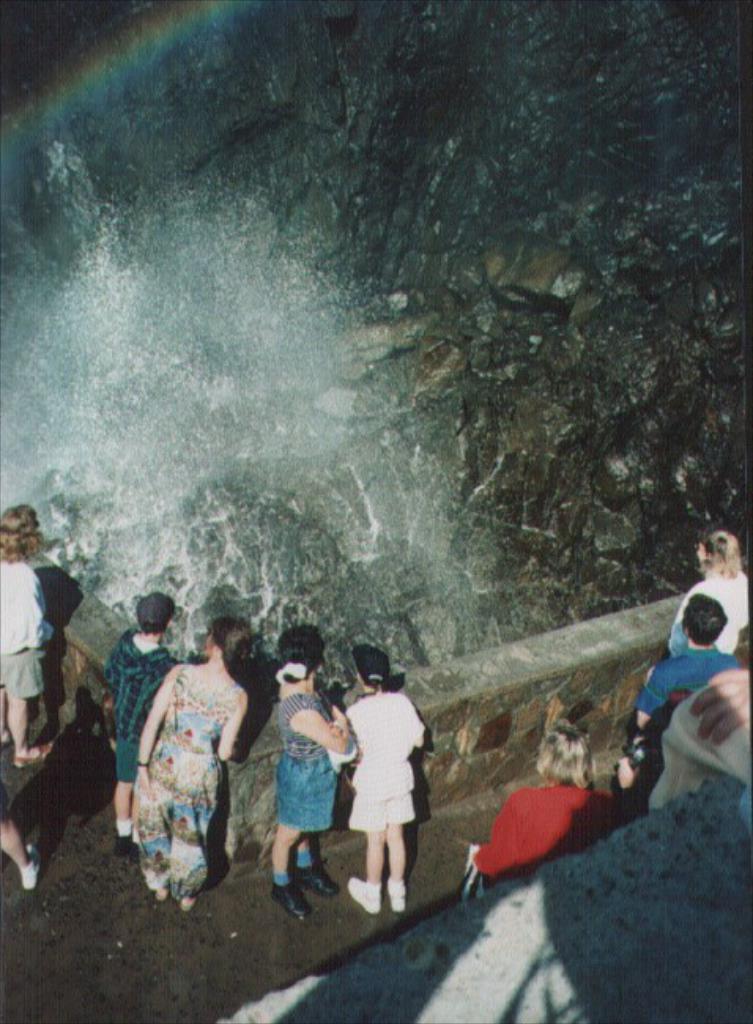How would you summarize this image in a sentence or two? There are some people standing near to a wall. There is a waterfall. Also there are rocks. 